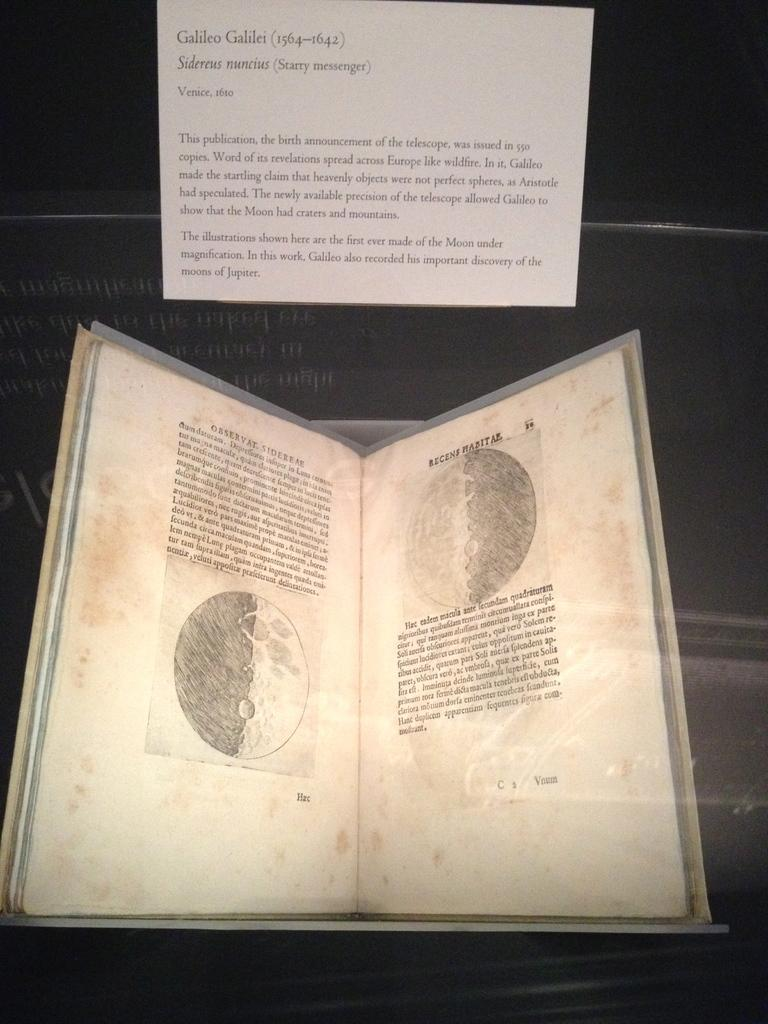<image>
Describe the image concisely. A print of Galileo Galilei's announcement of the invention of the telescope as shown in a museum. 